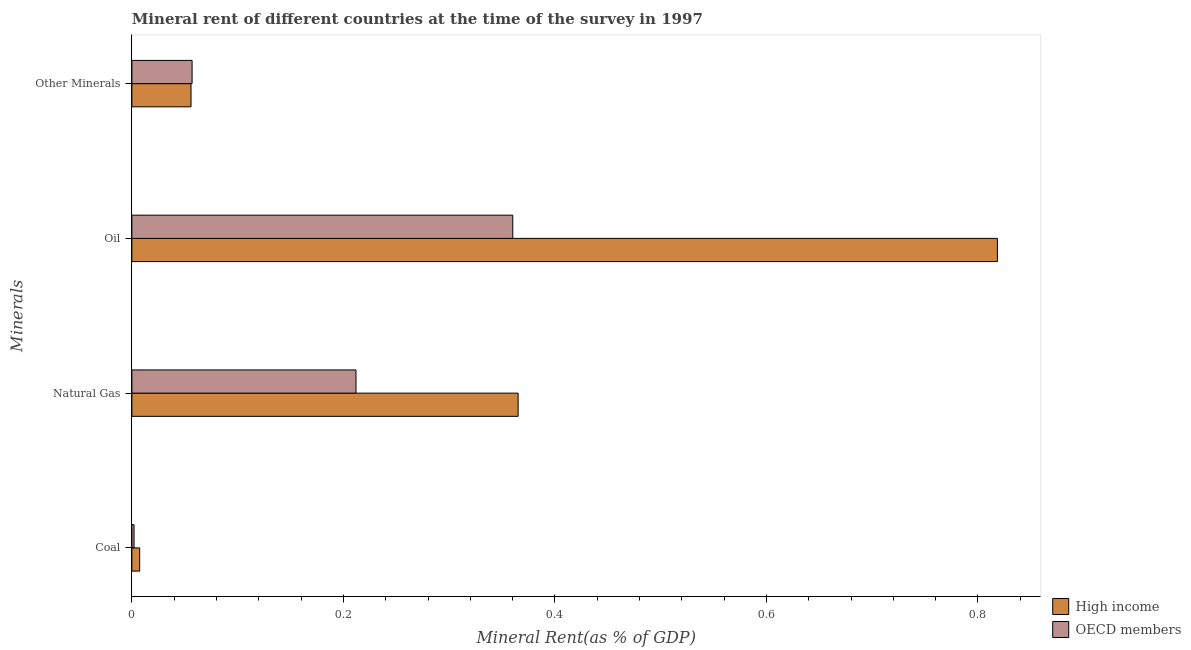How many different coloured bars are there?
Ensure brevity in your answer.  2. Are the number of bars on each tick of the Y-axis equal?
Provide a succinct answer. Yes. How many bars are there on the 4th tick from the top?
Provide a succinct answer. 2. How many bars are there on the 1st tick from the bottom?
Your response must be concise. 2. What is the label of the 2nd group of bars from the top?
Give a very brief answer. Oil. What is the  rent of other minerals in OECD members?
Make the answer very short. 0.06. Across all countries, what is the maximum  rent of other minerals?
Your response must be concise. 0.06. Across all countries, what is the minimum oil rent?
Your answer should be compact. 0.36. What is the total oil rent in the graph?
Offer a very short reply. 1.18. What is the difference between the  rent of other minerals in High income and that in OECD members?
Provide a short and direct response. -0. What is the difference between the coal rent in OECD members and the oil rent in High income?
Make the answer very short. -0.82. What is the average oil rent per country?
Offer a terse response. 0.59. What is the difference between the natural gas rent and  rent of other minerals in High income?
Offer a very short reply. 0.31. In how many countries, is the oil rent greater than 0.56 %?
Give a very brief answer. 1. What is the ratio of the coal rent in OECD members to that in High income?
Provide a short and direct response. 0.28. Is the difference between the coal rent in OECD members and High income greater than the difference between the oil rent in OECD members and High income?
Ensure brevity in your answer.  Yes. What is the difference between the highest and the second highest natural gas rent?
Ensure brevity in your answer.  0.15. What is the difference between the highest and the lowest oil rent?
Ensure brevity in your answer.  0.46. In how many countries, is the  rent of other minerals greater than the average  rent of other minerals taken over all countries?
Make the answer very short. 1. What does the 2nd bar from the top in Coal represents?
Your answer should be very brief. High income. How many bars are there?
Ensure brevity in your answer.  8. Are all the bars in the graph horizontal?
Provide a short and direct response. Yes. How many countries are there in the graph?
Offer a terse response. 2. What is the difference between two consecutive major ticks on the X-axis?
Give a very brief answer. 0.2. Does the graph contain any zero values?
Your answer should be compact. No. Where does the legend appear in the graph?
Provide a succinct answer. Bottom right. How many legend labels are there?
Your response must be concise. 2. How are the legend labels stacked?
Keep it short and to the point. Vertical. What is the title of the graph?
Provide a succinct answer. Mineral rent of different countries at the time of the survey in 1997. Does "Sint Maarten (Dutch part)" appear as one of the legend labels in the graph?
Provide a short and direct response. No. What is the label or title of the X-axis?
Provide a short and direct response. Mineral Rent(as % of GDP). What is the label or title of the Y-axis?
Provide a succinct answer. Minerals. What is the Mineral Rent(as % of GDP) in High income in Coal?
Offer a very short reply. 0.01. What is the Mineral Rent(as % of GDP) in OECD members in Coal?
Make the answer very short. 0. What is the Mineral Rent(as % of GDP) of High income in Natural Gas?
Provide a succinct answer. 0.37. What is the Mineral Rent(as % of GDP) in OECD members in Natural Gas?
Make the answer very short. 0.21. What is the Mineral Rent(as % of GDP) in High income in Oil?
Offer a very short reply. 0.82. What is the Mineral Rent(as % of GDP) of OECD members in Oil?
Provide a short and direct response. 0.36. What is the Mineral Rent(as % of GDP) in High income in Other Minerals?
Your response must be concise. 0.06. What is the Mineral Rent(as % of GDP) of OECD members in Other Minerals?
Offer a very short reply. 0.06. Across all Minerals, what is the maximum Mineral Rent(as % of GDP) of High income?
Provide a succinct answer. 0.82. Across all Minerals, what is the maximum Mineral Rent(as % of GDP) in OECD members?
Your answer should be very brief. 0.36. Across all Minerals, what is the minimum Mineral Rent(as % of GDP) of High income?
Your answer should be very brief. 0.01. Across all Minerals, what is the minimum Mineral Rent(as % of GDP) in OECD members?
Your answer should be compact. 0. What is the total Mineral Rent(as % of GDP) of High income in the graph?
Provide a short and direct response. 1.25. What is the total Mineral Rent(as % of GDP) of OECD members in the graph?
Provide a succinct answer. 0.63. What is the difference between the Mineral Rent(as % of GDP) of High income in Coal and that in Natural Gas?
Ensure brevity in your answer.  -0.36. What is the difference between the Mineral Rent(as % of GDP) in OECD members in Coal and that in Natural Gas?
Your answer should be compact. -0.21. What is the difference between the Mineral Rent(as % of GDP) in High income in Coal and that in Oil?
Your answer should be very brief. -0.81. What is the difference between the Mineral Rent(as % of GDP) of OECD members in Coal and that in Oil?
Offer a very short reply. -0.36. What is the difference between the Mineral Rent(as % of GDP) in High income in Coal and that in Other Minerals?
Make the answer very short. -0.05. What is the difference between the Mineral Rent(as % of GDP) in OECD members in Coal and that in Other Minerals?
Your response must be concise. -0.05. What is the difference between the Mineral Rent(as % of GDP) of High income in Natural Gas and that in Oil?
Your answer should be very brief. -0.45. What is the difference between the Mineral Rent(as % of GDP) in OECD members in Natural Gas and that in Oil?
Offer a very short reply. -0.15. What is the difference between the Mineral Rent(as % of GDP) of High income in Natural Gas and that in Other Minerals?
Your answer should be compact. 0.31. What is the difference between the Mineral Rent(as % of GDP) in OECD members in Natural Gas and that in Other Minerals?
Give a very brief answer. 0.15. What is the difference between the Mineral Rent(as % of GDP) of High income in Oil and that in Other Minerals?
Provide a succinct answer. 0.76. What is the difference between the Mineral Rent(as % of GDP) of OECD members in Oil and that in Other Minerals?
Your response must be concise. 0.3. What is the difference between the Mineral Rent(as % of GDP) of High income in Coal and the Mineral Rent(as % of GDP) of OECD members in Natural Gas?
Your answer should be compact. -0.2. What is the difference between the Mineral Rent(as % of GDP) of High income in Coal and the Mineral Rent(as % of GDP) of OECD members in Oil?
Your answer should be compact. -0.35. What is the difference between the Mineral Rent(as % of GDP) of High income in Coal and the Mineral Rent(as % of GDP) of OECD members in Other Minerals?
Make the answer very short. -0.05. What is the difference between the Mineral Rent(as % of GDP) of High income in Natural Gas and the Mineral Rent(as % of GDP) of OECD members in Oil?
Your answer should be very brief. 0.01. What is the difference between the Mineral Rent(as % of GDP) in High income in Natural Gas and the Mineral Rent(as % of GDP) in OECD members in Other Minerals?
Provide a short and direct response. 0.31. What is the difference between the Mineral Rent(as % of GDP) in High income in Oil and the Mineral Rent(as % of GDP) in OECD members in Other Minerals?
Your answer should be compact. 0.76. What is the average Mineral Rent(as % of GDP) in High income per Minerals?
Your response must be concise. 0.31. What is the average Mineral Rent(as % of GDP) in OECD members per Minerals?
Keep it short and to the point. 0.16. What is the difference between the Mineral Rent(as % of GDP) in High income and Mineral Rent(as % of GDP) in OECD members in Coal?
Your answer should be compact. 0.01. What is the difference between the Mineral Rent(as % of GDP) in High income and Mineral Rent(as % of GDP) in OECD members in Natural Gas?
Give a very brief answer. 0.15. What is the difference between the Mineral Rent(as % of GDP) of High income and Mineral Rent(as % of GDP) of OECD members in Oil?
Give a very brief answer. 0.46. What is the difference between the Mineral Rent(as % of GDP) in High income and Mineral Rent(as % of GDP) in OECD members in Other Minerals?
Make the answer very short. -0. What is the ratio of the Mineral Rent(as % of GDP) in High income in Coal to that in Natural Gas?
Offer a terse response. 0.02. What is the ratio of the Mineral Rent(as % of GDP) in OECD members in Coal to that in Natural Gas?
Provide a succinct answer. 0.01. What is the ratio of the Mineral Rent(as % of GDP) in High income in Coal to that in Oil?
Your response must be concise. 0.01. What is the ratio of the Mineral Rent(as % of GDP) in OECD members in Coal to that in Oil?
Your answer should be very brief. 0.01. What is the ratio of the Mineral Rent(as % of GDP) in High income in Coal to that in Other Minerals?
Your response must be concise. 0.13. What is the ratio of the Mineral Rent(as % of GDP) in OECD members in Coal to that in Other Minerals?
Provide a succinct answer. 0.04. What is the ratio of the Mineral Rent(as % of GDP) of High income in Natural Gas to that in Oil?
Keep it short and to the point. 0.45. What is the ratio of the Mineral Rent(as % of GDP) of OECD members in Natural Gas to that in Oil?
Ensure brevity in your answer.  0.59. What is the ratio of the Mineral Rent(as % of GDP) in High income in Natural Gas to that in Other Minerals?
Your response must be concise. 6.53. What is the ratio of the Mineral Rent(as % of GDP) in OECD members in Natural Gas to that in Other Minerals?
Make the answer very short. 3.72. What is the ratio of the Mineral Rent(as % of GDP) of High income in Oil to that in Other Minerals?
Offer a terse response. 14.63. What is the ratio of the Mineral Rent(as % of GDP) of OECD members in Oil to that in Other Minerals?
Your answer should be compact. 6.32. What is the difference between the highest and the second highest Mineral Rent(as % of GDP) in High income?
Ensure brevity in your answer.  0.45. What is the difference between the highest and the second highest Mineral Rent(as % of GDP) in OECD members?
Offer a terse response. 0.15. What is the difference between the highest and the lowest Mineral Rent(as % of GDP) of High income?
Keep it short and to the point. 0.81. What is the difference between the highest and the lowest Mineral Rent(as % of GDP) of OECD members?
Offer a terse response. 0.36. 